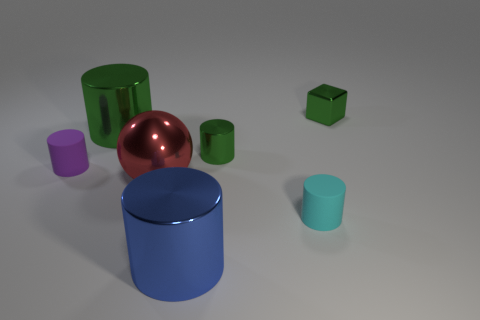Are there any other things that have the same material as the red thing?
Provide a short and direct response. Yes. Are the cylinder that is behind the tiny green metal cylinder and the small purple object made of the same material?
Ensure brevity in your answer.  No. Is the number of large metallic things behind the tiny shiny cylinder less than the number of gray shiny spheres?
Provide a succinct answer. No. How many metal things are small cubes or red balls?
Give a very brief answer. 2. Is the color of the large shiny sphere the same as the block?
Keep it short and to the point. No. Is there anything else that has the same color as the small shiny cylinder?
Provide a succinct answer. Yes. There is a large metallic object that is on the left side of the big sphere; does it have the same shape as the rubber thing right of the red sphere?
Your response must be concise. Yes. How many objects are green cylinders or green objects that are on the left side of the cyan rubber object?
Provide a succinct answer. 2. How many other things are there of the same size as the cyan thing?
Your response must be concise. 3. Is the tiny thing to the left of the large blue metallic thing made of the same material as the tiny object that is behind the big green metallic object?
Your answer should be compact. No. 